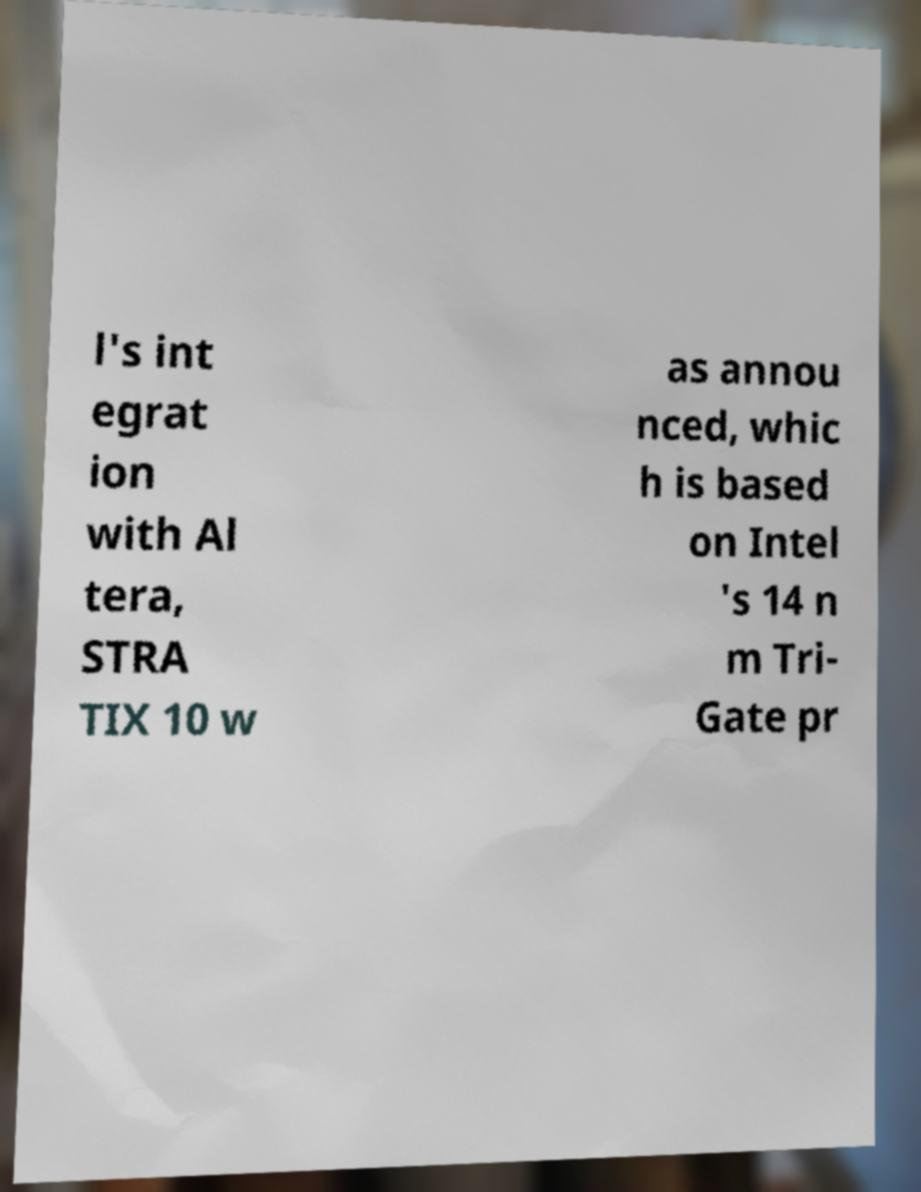Could you extract and type out the text from this image? l's int egrat ion with Al tera, STRA TIX 10 w as annou nced, whic h is based on Intel 's 14 n m Tri- Gate pr 